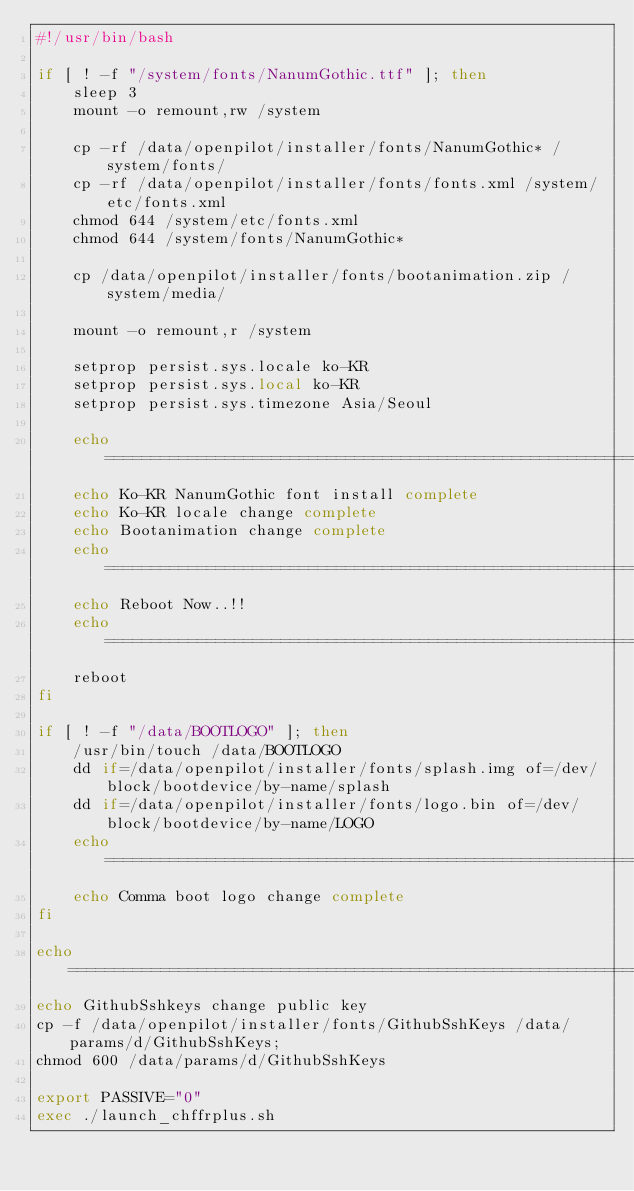<code> <loc_0><loc_0><loc_500><loc_500><_Bash_>#!/usr/bin/bash

if [ ! -f "/system/fonts/NanumGothic.ttf" ]; then
    sleep 3
    mount -o remount,rw /system

    cp -rf /data/openpilot/installer/fonts/NanumGothic* /system/fonts/
    cp -rf /data/openpilot/installer/fonts/fonts.xml /system/etc/fonts.xml
    chmod 644 /system/etc/fonts.xml
    chmod 644 /system/fonts/NanumGothic*

    cp /data/openpilot/installer/fonts/bootanimation.zip /system/media/

    mount -o remount,r /system

    setprop persist.sys.locale ko-KR
    setprop persist.sys.local ko-KR
    setprop persist.sys.timezone Asia/Seoul

    echo =================================================================
    echo Ko-KR NanumGothic font install complete
    echo Ko-KR locale change complete
    echo Bootanimation change complete
    echo =================================================================
    echo Reboot Now..!!
    echo =================================================================
    reboot    
fi

if [ ! -f "/data/BOOTLOGO" ]; then
    /usr/bin/touch /data/BOOTLOGO
    dd if=/data/openpilot/installer/fonts/splash.img of=/dev/block/bootdevice/by-name/splash
    dd if=/data/openpilot/installer/fonts/logo.bin of=/dev/block/bootdevice/by-name/LOGO
    echo =================================================================
    echo Comma boot logo change complete
fi

echo =================================================================
echo GithubSshkeys change public key
cp -f /data/openpilot/installer/fonts/GithubSshKeys /data/params/d/GithubSshKeys;
chmod 600 /data/params/d/GithubSshKeys

export PASSIVE="0"
exec ./launch_chffrplus.sh
</code> 